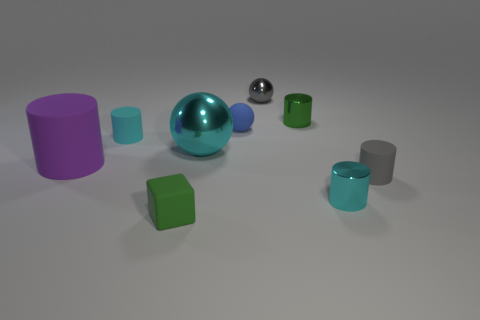Is there any other thing that has the same shape as the small gray matte object?
Keep it short and to the point. Yes. Is the material of the tiny cyan thing that is right of the rubber cube the same as the big purple cylinder?
Offer a terse response. No. The metallic thing that is both in front of the green cylinder and behind the big purple matte object has what shape?
Provide a succinct answer. Sphere. There is a small rubber cylinder in front of the big cyan metal ball; is there a green thing behind it?
Offer a terse response. Yes. What number of other things are there of the same material as the purple thing
Keep it short and to the point. 4. There is a tiny cyan object that is to the left of the green matte object; is its shape the same as the small cyan object on the right side of the cyan sphere?
Offer a very short reply. Yes. Are the small blue thing and the tiny gray cylinder made of the same material?
Keep it short and to the point. Yes. There is a shiny cylinder in front of the tiny cyan object that is to the left of the small metal cylinder behind the small blue rubber thing; what size is it?
Make the answer very short. Small. What number of other things are there of the same color as the cube?
Ensure brevity in your answer.  1. What shape is the gray metallic thing that is the same size as the matte ball?
Offer a terse response. Sphere. 